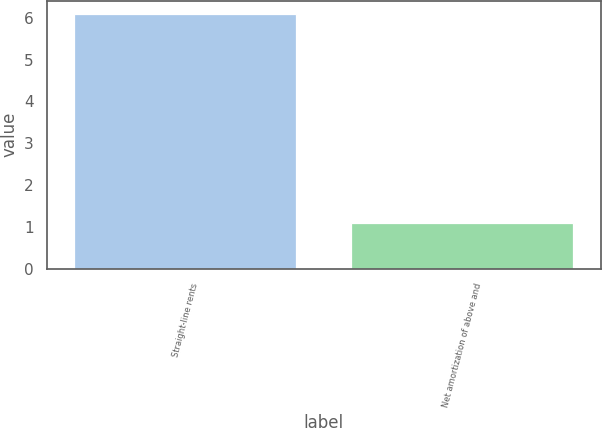Convert chart. <chart><loc_0><loc_0><loc_500><loc_500><bar_chart><fcel>Straight-line rents<fcel>Net amortization of above and<nl><fcel>6.1<fcel>1.1<nl></chart> 